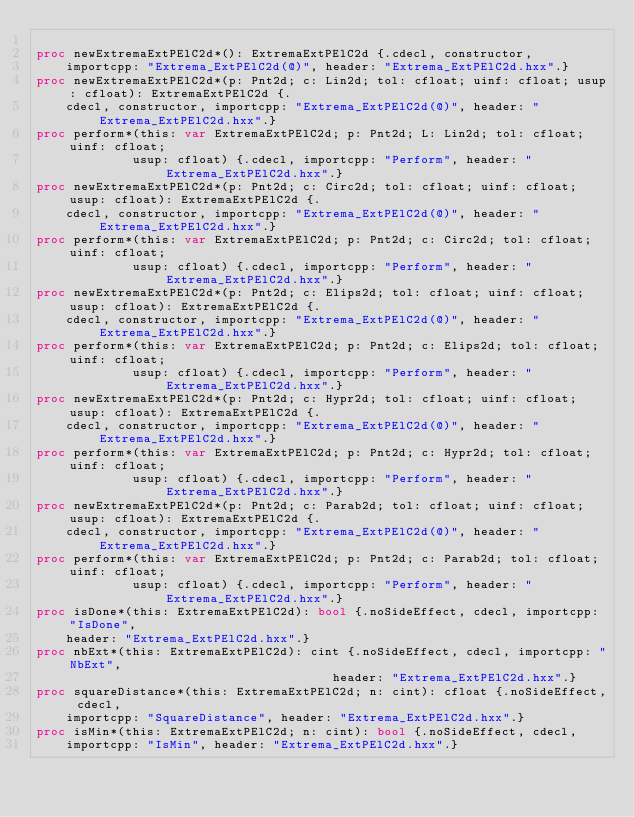<code> <loc_0><loc_0><loc_500><loc_500><_Nim_>
proc newExtremaExtPElC2d*(): ExtremaExtPElC2d {.cdecl, constructor,
    importcpp: "Extrema_ExtPElC2d(@)", header: "Extrema_ExtPElC2d.hxx".}
proc newExtremaExtPElC2d*(p: Pnt2d; c: Lin2d; tol: cfloat; uinf: cfloat; usup: cfloat): ExtremaExtPElC2d {.
    cdecl, constructor, importcpp: "Extrema_ExtPElC2d(@)", header: "Extrema_ExtPElC2d.hxx".}
proc perform*(this: var ExtremaExtPElC2d; p: Pnt2d; L: Lin2d; tol: cfloat; uinf: cfloat;
             usup: cfloat) {.cdecl, importcpp: "Perform", header: "Extrema_ExtPElC2d.hxx".}
proc newExtremaExtPElC2d*(p: Pnt2d; c: Circ2d; tol: cfloat; uinf: cfloat; usup: cfloat): ExtremaExtPElC2d {.
    cdecl, constructor, importcpp: "Extrema_ExtPElC2d(@)", header: "Extrema_ExtPElC2d.hxx".}
proc perform*(this: var ExtremaExtPElC2d; p: Pnt2d; c: Circ2d; tol: cfloat; uinf: cfloat;
             usup: cfloat) {.cdecl, importcpp: "Perform", header: "Extrema_ExtPElC2d.hxx".}
proc newExtremaExtPElC2d*(p: Pnt2d; c: Elips2d; tol: cfloat; uinf: cfloat; usup: cfloat): ExtremaExtPElC2d {.
    cdecl, constructor, importcpp: "Extrema_ExtPElC2d(@)", header: "Extrema_ExtPElC2d.hxx".}
proc perform*(this: var ExtremaExtPElC2d; p: Pnt2d; c: Elips2d; tol: cfloat; uinf: cfloat;
             usup: cfloat) {.cdecl, importcpp: "Perform", header: "Extrema_ExtPElC2d.hxx".}
proc newExtremaExtPElC2d*(p: Pnt2d; c: Hypr2d; tol: cfloat; uinf: cfloat; usup: cfloat): ExtremaExtPElC2d {.
    cdecl, constructor, importcpp: "Extrema_ExtPElC2d(@)", header: "Extrema_ExtPElC2d.hxx".}
proc perform*(this: var ExtremaExtPElC2d; p: Pnt2d; c: Hypr2d; tol: cfloat; uinf: cfloat;
             usup: cfloat) {.cdecl, importcpp: "Perform", header: "Extrema_ExtPElC2d.hxx".}
proc newExtremaExtPElC2d*(p: Pnt2d; c: Parab2d; tol: cfloat; uinf: cfloat; usup: cfloat): ExtremaExtPElC2d {.
    cdecl, constructor, importcpp: "Extrema_ExtPElC2d(@)", header: "Extrema_ExtPElC2d.hxx".}
proc perform*(this: var ExtremaExtPElC2d; p: Pnt2d; c: Parab2d; tol: cfloat; uinf: cfloat;
             usup: cfloat) {.cdecl, importcpp: "Perform", header: "Extrema_ExtPElC2d.hxx".}
proc isDone*(this: ExtremaExtPElC2d): bool {.noSideEffect, cdecl, importcpp: "IsDone",
    header: "Extrema_ExtPElC2d.hxx".}
proc nbExt*(this: ExtremaExtPElC2d): cint {.noSideEffect, cdecl, importcpp: "NbExt",
                                        header: "Extrema_ExtPElC2d.hxx".}
proc squareDistance*(this: ExtremaExtPElC2d; n: cint): cfloat {.noSideEffect, cdecl,
    importcpp: "SquareDistance", header: "Extrema_ExtPElC2d.hxx".}
proc isMin*(this: ExtremaExtPElC2d; n: cint): bool {.noSideEffect, cdecl,
    importcpp: "IsMin", header: "Extrema_ExtPElC2d.hxx".}</code> 